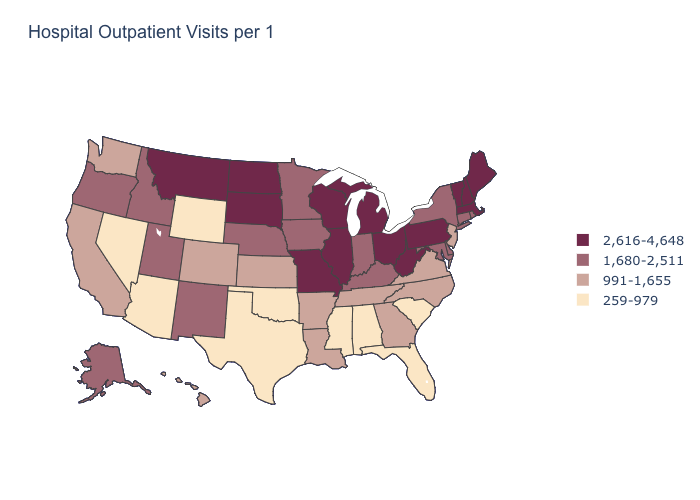Does the map have missing data?
Answer briefly. No. What is the value of Rhode Island?
Quick response, please. 1,680-2,511. How many symbols are there in the legend?
Answer briefly. 4. What is the lowest value in the Northeast?
Give a very brief answer. 991-1,655. Does Missouri have the highest value in the MidWest?
Answer briefly. Yes. Does North Dakota have the same value as Michigan?
Concise answer only. Yes. What is the value of Indiana?
Quick response, please. 1,680-2,511. Name the states that have a value in the range 991-1,655?
Answer briefly. Arkansas, California, Colorado, Georgia, Hawaii, Kansas, Louisiana, New Jersey, North Carolina, Tennessee, Virginia, Washington. Which states hav the highest value in the South?
Quick response, please. West Virginia. Does Tennessee have a higher value than Idaho?
Keep it brief. No. What is the value of Illinois?
Give a very brief answer. 2,616-4,648. Which states have the highest value in the USA?
Be succinct. Illinois, Maine, Massachusetts, Michigan, Missouri, Montana, New Hampshire, North Dakota, Ohio, Pennsylvania, South Dakota, Vermont, West Virginia, Wisconsin. Does the first symbol in the legend represent the smallest category?
Write a very short answer. No. What is the value of Wyoming?
Answer briefly. 259-979. Which states have the lowest value in the MidWest?
Concise answer only. Kansas. 